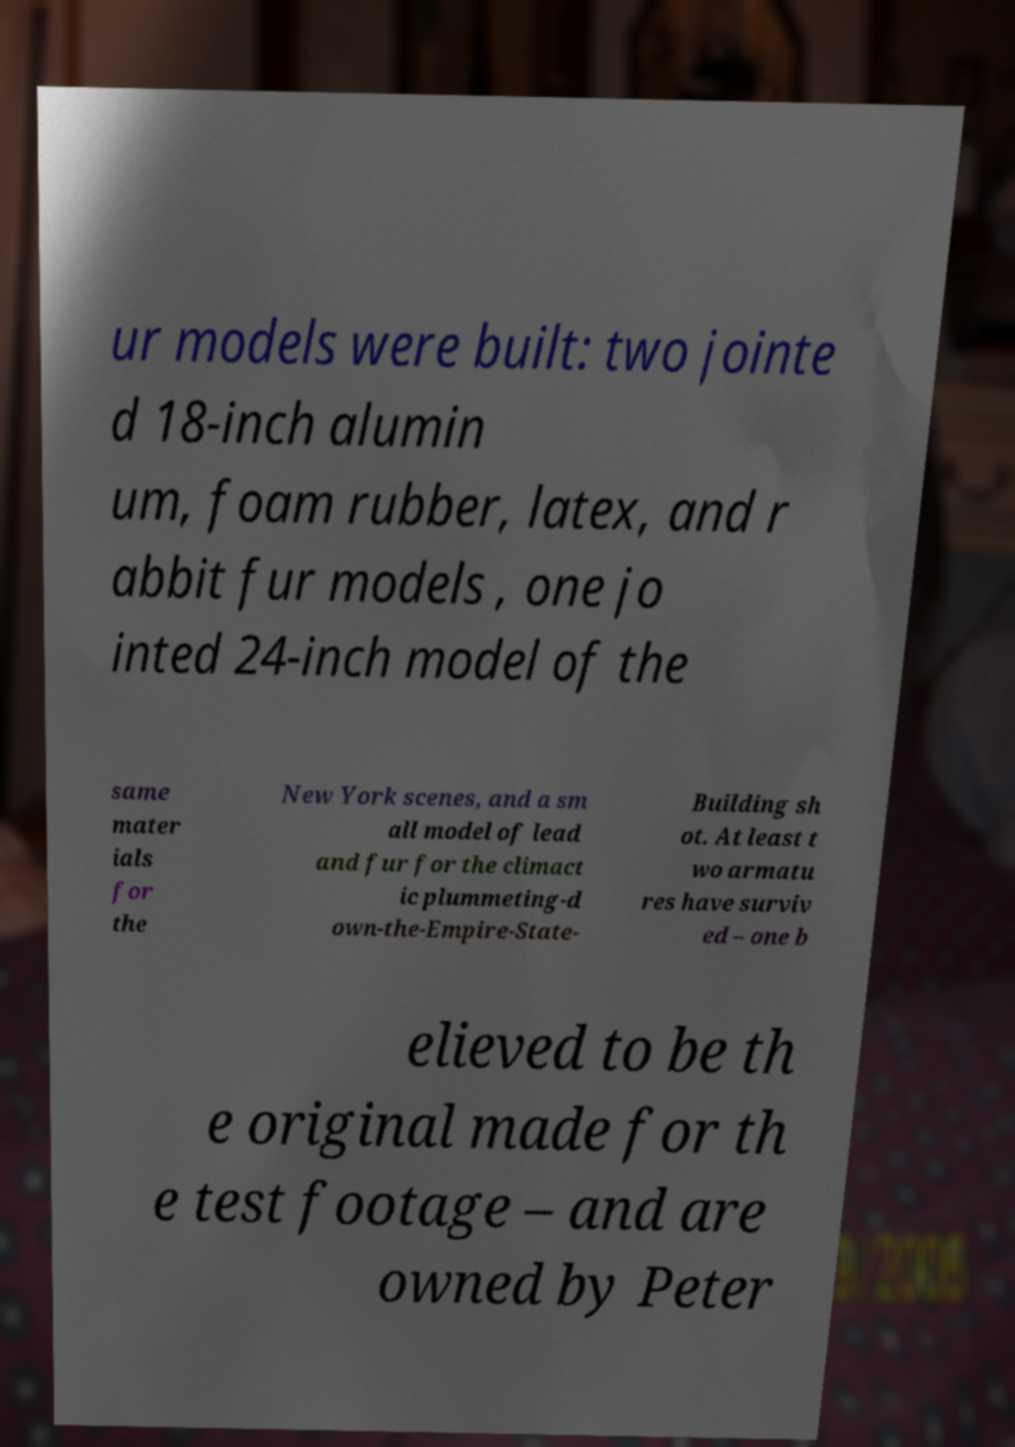There's text embedded in this image that I need extracted. Can you transcribe it verbatim? ur models were built: two jointe d 18-inch alumin um, foam rubber, latex, and r abbit fur models , one jo inted 24-inch model of the same mater ials for the New York scenes, and a sm all model of lead and fur for the climact ic plummeting-d own-the-Empire-State- Building sh ot. At least t wo armatu res have surviv ed – one b elieved to be th e original made for th e test footage – and are owned by Peter 